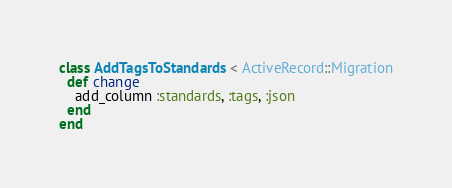Convert code to text. <code><loc_0><loc_0><loc_500><loc_500><_Ruby_>class AddTagsToStandards < ActiveRecord::Migration
  def change
    add_column :standards, :tags, :json
  end
end
</code> 